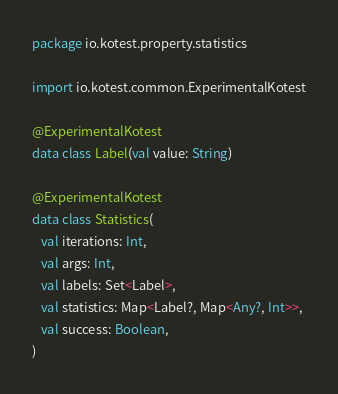Convert code to text. <code><loc_0><loc_0><loc_500><loc_500><_Kotlin_>package io.kotest.property.statistics

import io.kotest.common.ExperimentalKotest

@ExperimentalKotest
data class Label(val value: String)

@ExperimentalKotest
data class Statistics(
   val iterations: Int,
   val args: Int,
   val labels: Set<Label>,
   val statistics: Map<Label?, Map<Any?, Int>>,
   val success: Boolean,
)
</code> 